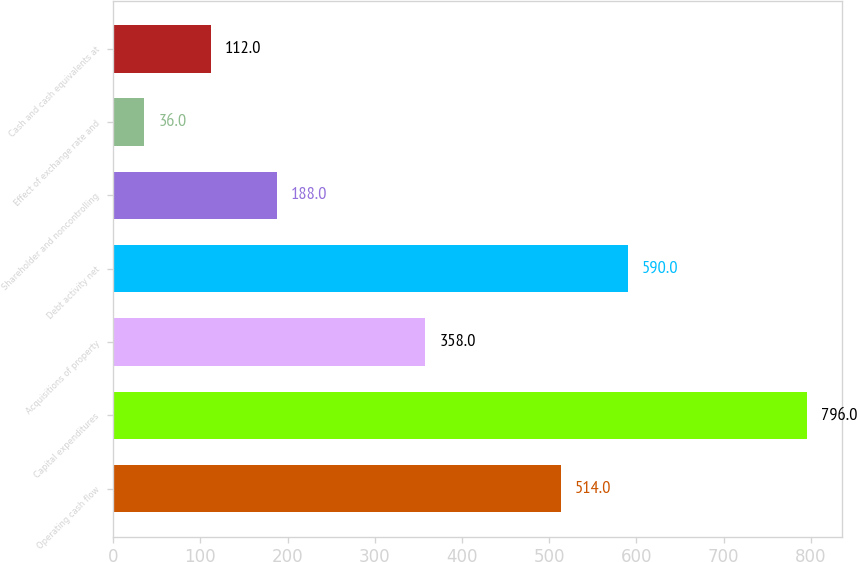Convert chart. <chart><loc_0><loc_0><loc_500><loc_500><bar_chart><fcel>Operating cash flow<fcel>Capital expenditures<fcel>Acquisitions of property<fcel>Debt activity net<fcel>Shareholder and noncontrolling<fcel>Effect of exchange rate and<fcel>Cash and cash equivalents at<nl><fcel>514<fcel>796<fcel>358<fcel>590<fcel>188<fcel>36<fcel>112<nl></chart> 